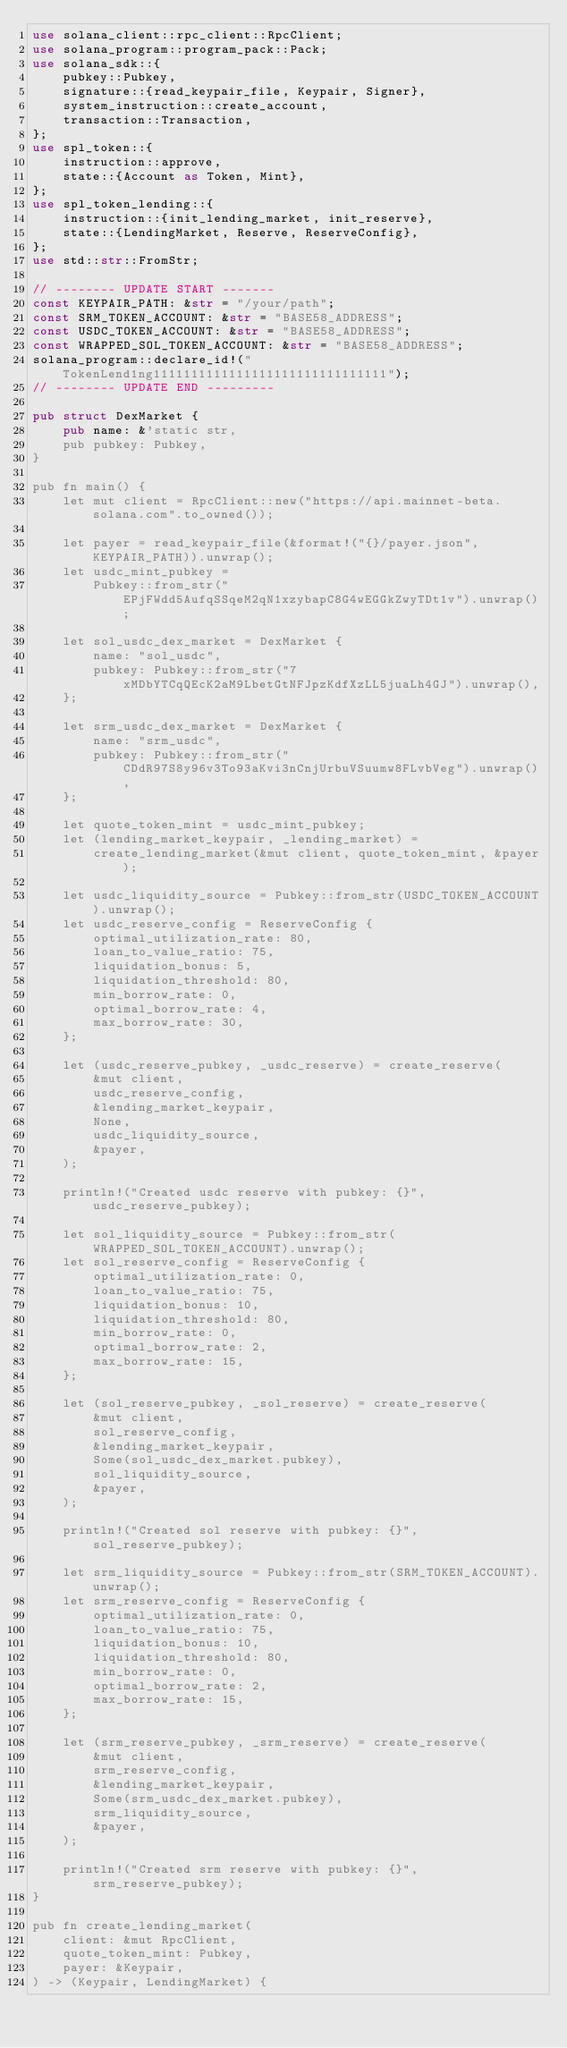Convert code to text. <code><loc_0><loc_0><loc_500><loc_500><_Rust_>use solana_client::rpc_client::RpcClient;
use solana_program::program_pack::Pack;
use solana_sdk::{
    pubkey::Pubkey,
    signature::{read_keypair_file, Keypair, Signer},
    system_instruction::create_account,
    transaction::Transaction,
};
use spl_token::{
    instruction::approve,
    state::{Account as Token, Mint},
};
use spl_token_lending::{
    instruction::{init_lending_market, init_reserve},
    state::{LendingMarket, Reserve, ReserveConfig},
};
use std::str::FromStr;

// -------- UPDATE START -------
const KEYPAIR_PATH: &str = "/your/path";
const SRM_TOKEN_ACCOUNT: &str = "BASE58_ADDRESS";
const USDC_TOKEN_ACCOUNT: &str = "BASE58_ADDRESS";
const WRAPPED_SOL_TOKEN_ACCOUNT: &str = "BASE58_ADDRESS";
solana_program::declare_id!("TokenLend1ng1111111111111111111111111111111");
// -------- UPDATE END ---------

pub struct DexMarket {
    pub name: &'static str,
    pub pubkey: Pubkey,
}

pub fn main() {
    let mut client = RpcClient::new("https://api.mainnet-beta.solana.com".to_owned());

    let payer = read_keypair_file(&format!("{}/payer.json", KEYPAIR_PATH)).unwrap();
    let usdc_mint_pubkey =
        Pubkey::from_str("EPjFWdd5AufqSSqeM2qN1xzybapC8G4wEGGkZwyTDt1v").unwrap();

    let sol_usdc_dex_market = DexMarket {
        name: "sol_usdc",
        pubkey: Pubkey::from_str("7xMDbYTCqQEcK2aM9LbetGtNFJpzKdfXzLL5juaLh4GJ").unwrap(),
    };

    let srm_usdc_dex_market = DexMarket {
        name: "srm_usdc",
        pubkey: Pubkey::from_str("CDdR97S8y96v3To93aKvi3nCnjUrbuVSuumw8FLvbVeg").unwrap(),
    };

    let quote_token_mint = usdc_mint_pubkey;
    let (lending_market_keypair, _lending_market) =
        create_lending_market(&mut client, quote_token_mint, &payer);

    let usdc_liquidity_source = Pubkey::from_str(USDC_TOKEN_ACCOUNT).unwrap();
    let usdc_reserve_config = ReserveConfig {
        optimal_utilization_rate: 80,
        loan_to_value_ratio: 75,
        liquidation_bonus: 5,
        liquidation_threshold: 80,
        min_borrow_rate: 0,
        optimal_borrow_rate: 4,
        max_borrow_rate: 30,
    };

    let (usdc_reserve_pubkey, _usdc_reserve) = create_reserve(
        &mut client,
        usdc_reserve_config,
        &lending_market_keypair,
        None,
        usdc_liquidity_source,
        &payer,
    );

    println!("Created usdc reserve with pubkey: {}", usdc_reserve_pubkey);

    let sol_liquidity_source = Pubkey::from_str(WRAPPED_SOL_TOKEN_ACCOUNT).unwrap();
    let sol_reserve_config = ReserveConfig {
        optimal_utilization_rate: 0,
        loan_to_value_ratio: 75,
        liquidation_bonus: 10,
        liquidation_threshold: 80,
        min_borrow_rate: 0,
        optimal_borrow_rate: 2,
        max_borrow_rate: 15,
    };

    let (sol_reserve_pubkey, _sol_reserve) = create_reserve(
        &mut client,
        sol_reserve_config,
        &lending_market_keypair,
        Some(sol_usdc_dex_market.pubkey),
        sol_liquidity_source,
        &payer,
    );

    println!("Created sol reserve with pubkey: {}", sol_reserve_pubkey);

    let srm_liquidity_source = Pubkey::from_str(SRM_TOKEN_ACCOUNT).unwrap();
    let srm_reserve_config = ReserveConfig {
        optimal_utilization_rate: 0,
        loan_to_value_ratio: 75,
        liquidation_bonus: 10,
        liquidation_threshold: 80,
        min_borrow_rate: 0,
        optimal_borrow_rate: 2,
        max_borrow_rate: 15,
    };

    let (srm_reserve_pubkey, _srm_reserve) = create_reserve(
        &mut client,
        srm_reserve_config,
        &lending_market_keypair,
        Some(srm_usdc_dex_market.pubkey),
        srm_liquidity_source,
        &payer,
    );

    println!("Created srm reserve with pubkey: {}", srm_reserve_pubkey);
}

pub fn create_lending_market(
    client: &mut RpcClient,
    quote_token_mint: Pubkey,
    payer: &Keypair,
) -> (Keypair, LendingMarket) {</code> 